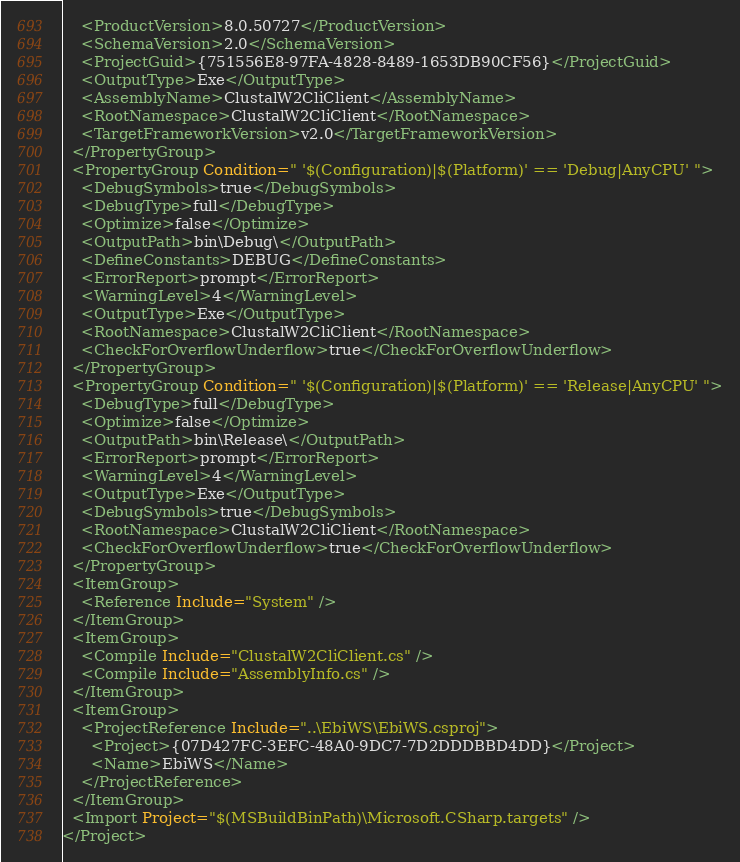<code> <loc_0><loc_0><loc_500><loc_500><_XML_>    <ProductVersion>8.0.50727</ProductVersion>
    <SchemaVersion>2.0</SchemaVersion>
    <ProjectGuid>{751556E8-97FA-4828-8489-1653DB90CF56}</ProjectGuid>
    <OutputType>Exe</OutputType>
    <AssemblyName>ClustalW2CliClient</AssemblyName>
    <RootNamespace>ClustalW2CliClient</RootNamespace>
    <TargetFrameworkVersion>v2.0</TargetFrameworkVersion>
  </PropertyGroup>
  <PropertyGroup Condition=" '$(Configuration)|$(Platform)' == 'Debug|AnyCPU' ">
    <DebugSymbols>true</DebugSymbols>
    <DebugType>full</DebugType>
    <Optimize>false</Optimize>
    <OutputPath>bin\Debug\</OutputPath>
    <DefineConstants>DEBUG</DefineConstants>
    <ErrorReport>prompt</ErrorReport>
    <WarningLevel>4</WarningLevel>
    <OutputType>Exe</OutputType>
    <RootNamespace>ClustalW2CliClient</RootNamespace>
    <CheckForOverflowUnderflow>true</CheckForOverflowUnderflow>
  </PropertyGroup>
  <PropertyGroup Condition=" '$(Configuration)|$(Platform)' == 'Release|AnyCPU' ">
    <DebugType>full</DebugType>
    <Optimize>false</Optimize>
    <OutputPath>bin\Release\</OutputPath>
    <ErrorReport>prompt</ErrorReport>
    <WarningLevel>4</WarningLevel>
    <OutputType>Exe</OutputType>
    <DebugSymbols>true</DebugSymbols>
    <RootNamespace>ClustalW2CliClient</RootNamespace>
    <CheckForOverflowUnderflow>true</CheckForOverflowUnderflow>
  </PropertyGroup>
  <ItemGroup>
    <Reference Include="System" />
  </ItemGroup>
  <ItemGroup>
    <Compile Include="ClustalW2CliClient.cs" />
    <Compile Include="AssemblyInfo.cs" />
  </ItemGroup>
  <ItemGroup>
    <ProjectReference Include="..\EbiWS\EbiWS.csproj">
      <Project>{07D427FC-3EFC-48A0-9DC7-7D2DDDBBD4DD}</Project>
      <Name>EbiWS</Name>
    </ProjectReference>
  </ItemGroup>
  <Import Project="$(MSBuildBinPath)\Microsoft.CSharp.targets" />
</Project></code> 